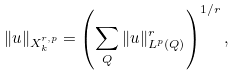<formula> <loc_0><loc_0><loc_500><loc_500>\| u \| _ { X ^ { r , p } _ { k } } = \left ( \sum _ { Q } \| u \| _ { L ^ { p } ( Q ) } ^ { r } \right ) ^ { 1 / r } ,</formula> 